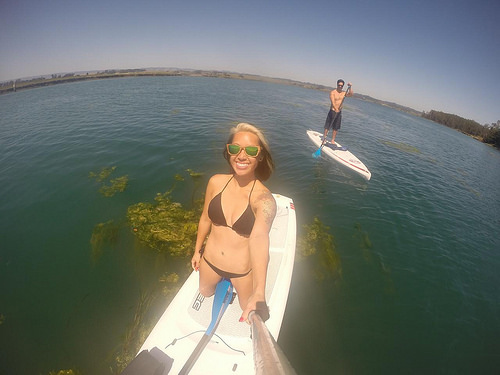<image>
Can you confirm if the water is under the man? Yes. The water is positioned underneath the man, with the man above it in the vertical space. 